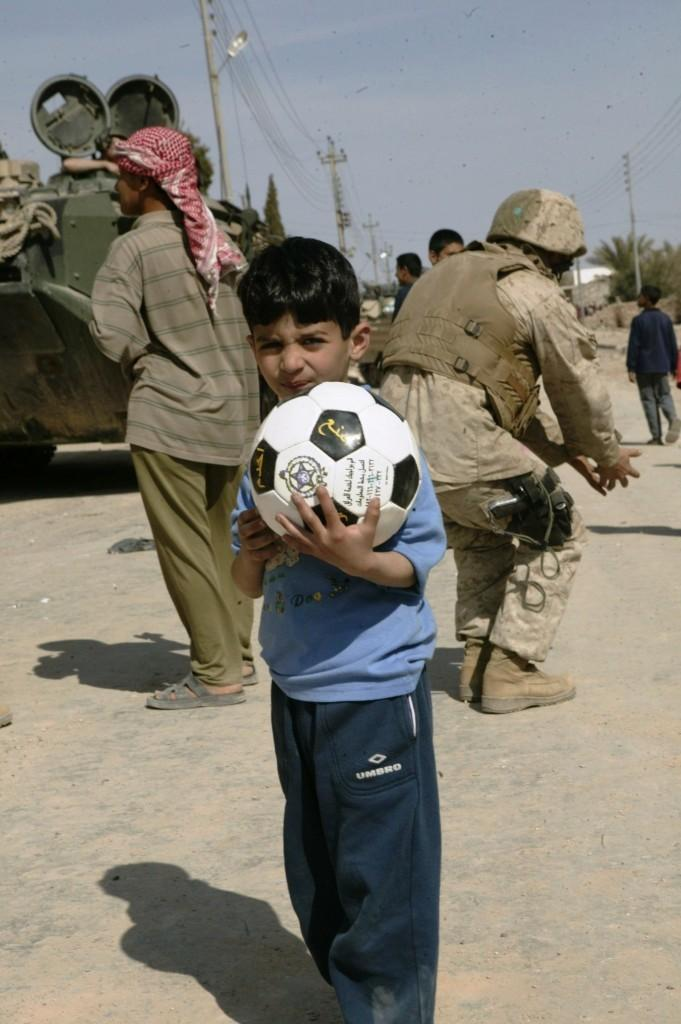What can be seen in the background of the image? There is a sky in the image. What type of pole is present in the image? There is a current pole in the image. What type of lighting fixture is visible in the image? There is a street lamp in the image. What type of object is present in the image that is used for transportation? There is a vehicle in the image. Are there any people present in the image? Yes, there are people in the image. Can you describe the boy in the image? The boy is standing in the image and is holding a ball. What type of jewel is hanging from the curtain in the image? There is no curtain or jewel present in the image. What type of advertisement is visible on the street lamp in the image? There is no advertisement present on the street lamp in the image. 